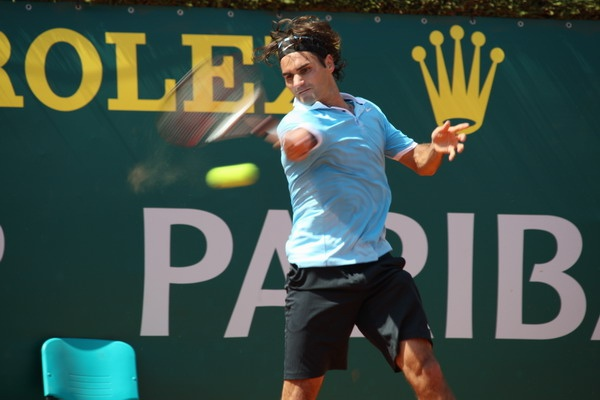Describe the objects in this image and their specific colors. I can see people in black and gray tones, tennis racket in black, gray, and tan tones, chair in black, turquoise, and teal tones, and sports ball in black, khaki, and olive tones in this image. 